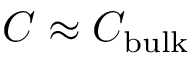<formula> <loc_0><loc_0><loc_500><loc_500>C \approx C _ { b u l k }</formula> 